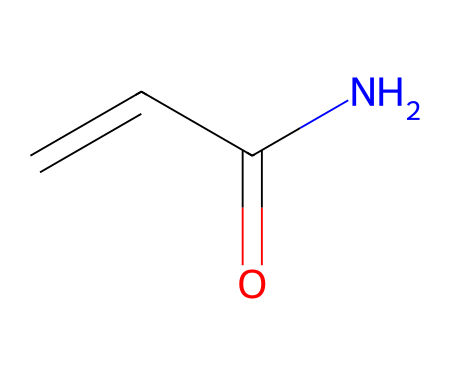What is the molecular formula of acrylamide? The SMILES representation (C=CC(=O)N) indicates the presence of carbon (C), hydrogen (H), nitrogen (N), and oxygen (O) atoms. Counting these, we find there are 3 carbon atoms, 5 hydrogen atoms, 1 nitrogen atom, and 1 oxygen atom, leading to the molecular formula C3H5NO.
Answer: C3H5NO How many double bonds are present in acrylamide? In the SMILES representation, we can see two double bonds: one between the first carbon and the second carbon (C=C), and another between the second carbon and the oxygen (C=O). Therefore, there are 2 double bonds in acrylamide.
Answer: 2 Which part of the structure indicates acrylamide's functionality as a monomer? The presence of the amide functional group (C(=O)N) in the structure signifies that acrylamide can undergo polymerization. This is an essential feature of a monomer, allowing it to link to other monomers to form polymers.
Answer: amide functional group Is there a nitrogen atom in the chemical structure of acrylamide? Yes, the SMILES notation contains an 'N' which represents a nitrogen atom, specifically in the amide functional group, confirming its presence in the molecule's structure.
Answer: Yes What is the total number of hydrogen atoms in acrylamide? The molecular formula derived from the SMILES shows there are 5 hydrogen atoms attached to the three carbon atoms and the nitrogen atom within the acrylamide structure.
Answer: 5 Which atom is directly bonded to the double-bonded oxygen in acrylamide? The structure shows that the carbon (C) atom is directly bonded to the double-bonded oxygen (C=O) in the amide functional group. Thus, the carbon is the atom in question.
Answer: carbon 